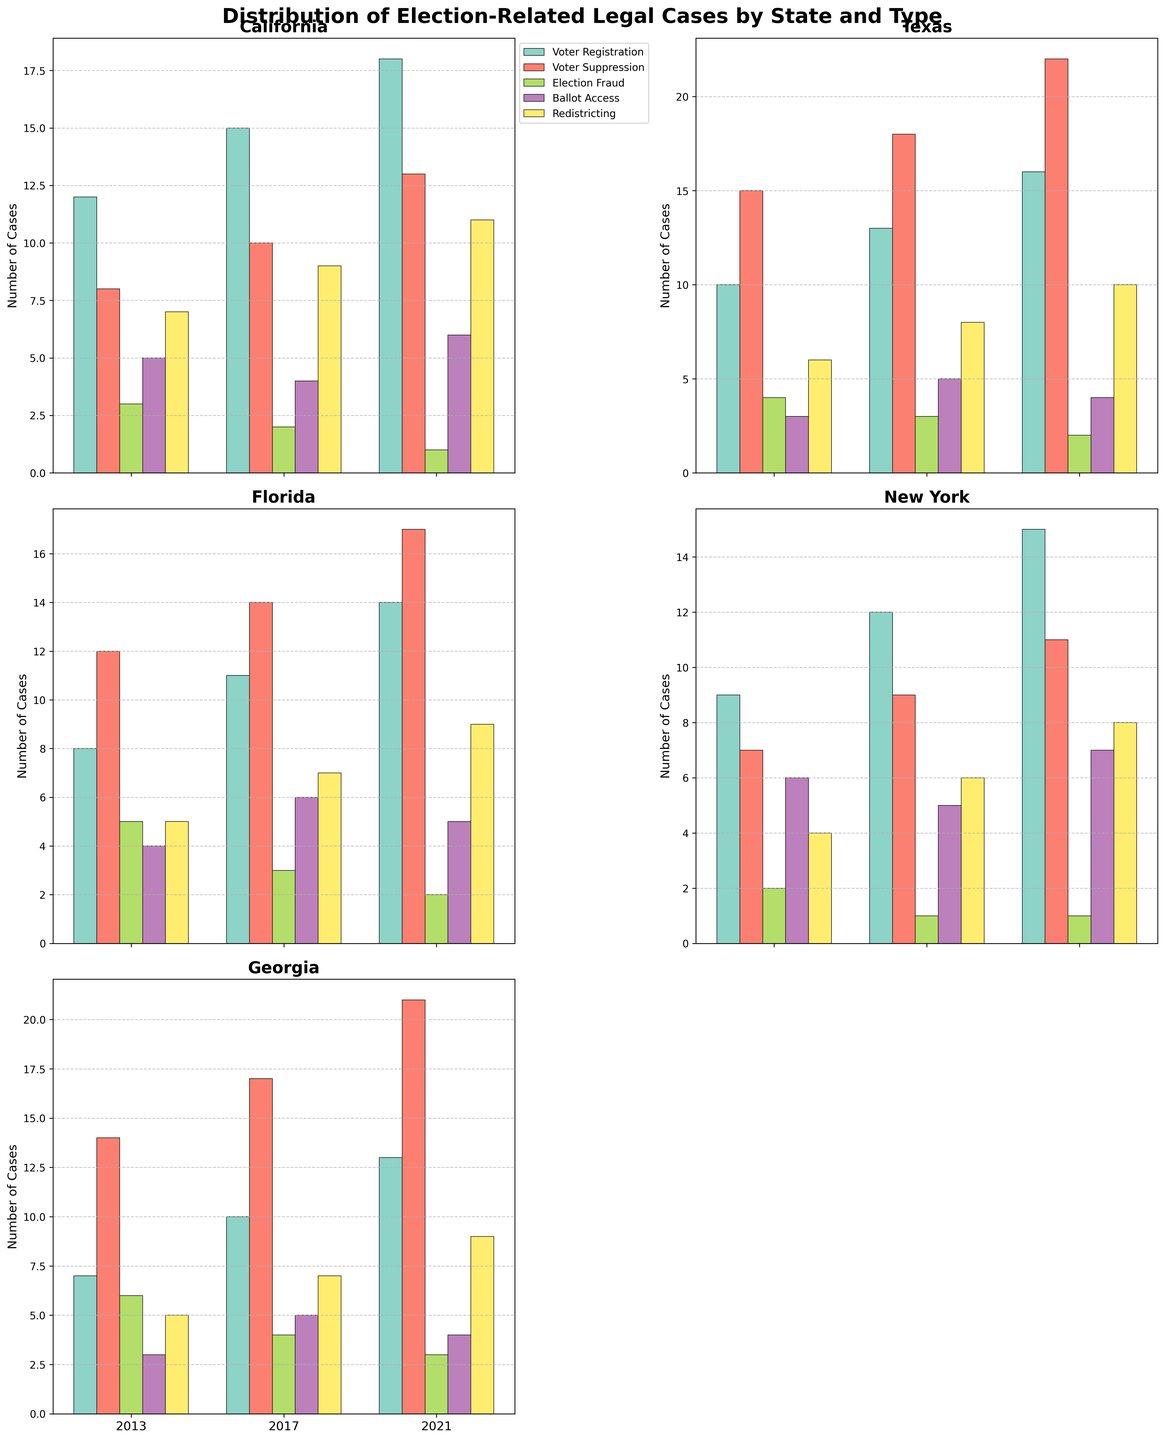How many total cases of Voter Registration issues were reported in California for the years listed? The data for Voter Registration cases in California are 12 (2013), 15 (2017), and 18 (2021). Summing them up: 12 + 15 + 18 = 45.
Answer: 45 Which state had the highest number of Voter Suppression cases in 2021? The figure shows Voter Suppression cases for each state in 2021. California has 13, Texas has 22, Florida has 17, New York has 11, and Georgia has 21. Texas has the highest number.
Answer: Texas What is the average number of Election Fraud cases across all states in 2017? The data for Election Fraud cases across all states in 2017 are: California (2), Texas (3), Florida (3), New York (1), and Georgia (4). The average is calculated as (2 + 3 + 3 + 1 + 4) / 5 = 13 / 5 = 2.6.
Answer: 2.6 How did the number of Ballot Access cases change in Georgia from 2013 to 2021? In 2013, Georgia had 3 Ballot Access cases, and in 2021, it had 4. The change is calculated as 4 - 3 = 1.
Answer: Increased by 1 Which category has the most significant increase in cases in California between 2013 and 2021? By examining the plot for California, we note the increases: Voter Registration (18 - 12 = 6), Voter Suppression (13 - 8 = 5), Election Fraud (1 - 3 = -2), Ballot Access (6 - 5 = 1), and Redistricting (11 - 7 = 4). Voter Registration has the most significant increase of 6.
Answer: Voter Registration Compare the number of Redistricting cases in Florida to Texas in 2017. Which state has more? In 2017, Florida has 7 Redistricting cases, while Texas has 8. Texas has more Redistricting cases.
Answer: Texas What is the combined total of Voter Suppression cases in New York for all listed years? The Voter Suppression cases in New York are 7 (2013), 9 (2017), and 11 (2021). The combined total is 7 + 9 + 11 = 27.
Answer: 27 Is the trend of Election Fraud cases increasing or decreasing in Texas from 2013 to 2021? According to the plot, the numbers are: 2013 (4), 2017 (3), and 2021 (2), showing a decreasing trend.
Answer: Decreasing Which state has the smallest number of Ballot Access cases in 2013? Looking at the plot for 2013, the number of Ballot Access cases are: California (5), Texas (3), Florida (4), New York (6), and Georgia (3). Texas and Georgia both have the smallest number with 3 cases each.
Answer: Texas and Georgia What is the total number of legal cases across all categories in Georgia for 2017? Georgia's cases in 2017: Voter Registration (10), Voter Suppression (17), Election Fraud (4), Ballot Access (5), and Redistricting (7). The total is 10 + 17 + 4 + 5 + 7 = 43.
Answer: 43 